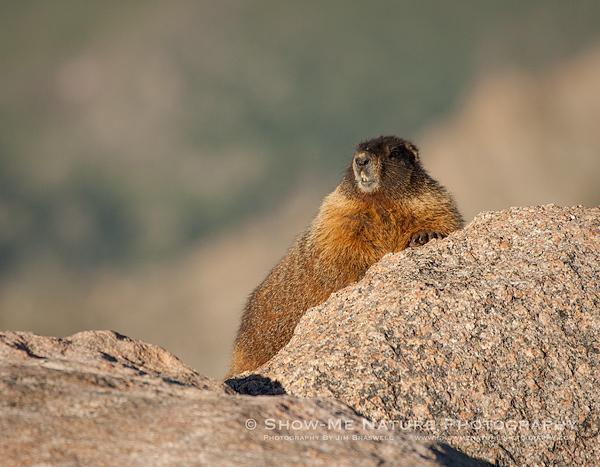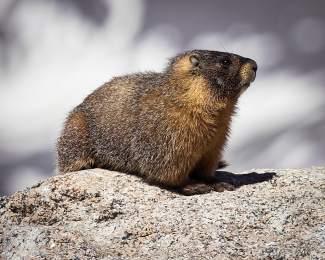The first image is the image on the left, the second image is the image on the right. Examine the images to the left and right. Is the description "the animal on the right image is facing left" accurate? Answer yes or no. No. 